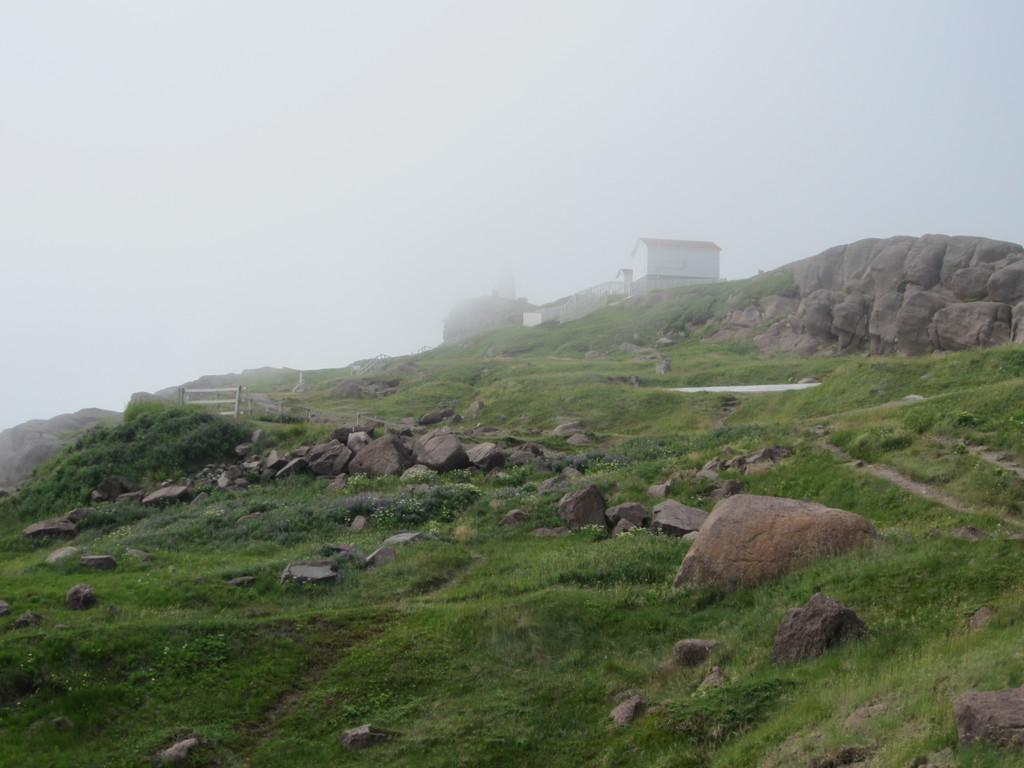What type of location is depicted in the image? The image depicts a hill station. What can be seen on the ground in the image? There is beautiful grass in the image. What other natural elements are present in the image? There are rocks in the image. Where is the house located in the image? The house is on the right side of the image. How is the house affected by the weather in the image? The house is covered with fog. What type of society is depicted in the image? There is no society depicted in the image; it shows a hill station with a house and natural elements. What is the cent used for in the image? There is no cent present in the image. 